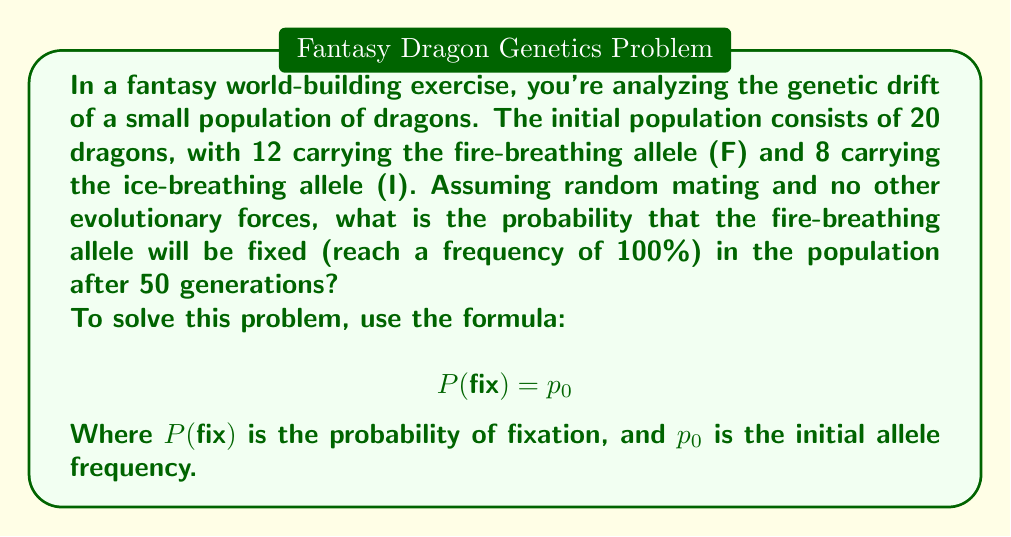Help me with this question. To solve this problem, we need to follow these steps:

1. Calculate the initial allele frequency ($p_0$) of the fire-breathing allele (F):

   $p_0 = \frac{\text{Number of F alleles}}{\text{Total number of alleles}}$

   $p_0 = \frac{12}{20} = 0.6$

2. Apply the formula for the probability of fixation:

   $$ P(fix) = p_0 $$

   This formula is derived from the neutral theory of molecular evolution, which states that in the absence of selection, the probability of an allele becoming fixed in a population is equal to its initial frequency.

3. Substitute the value of $p_0$ into the formula:

   $$ P(fix) = 0.6 $$

It's important to note that this probability is independent of the population size and the number of generations, as long as there are no other evolutionary forces at play. The 50 generations mentioned in the question don't affect the calculation, but they provide enough time for genetic drift to potentially lead to fixation.

In the context of world-building, this result suggests that if you were to simulate this scenario multiple times, about 60% of the time, all dragons would end up as fire-breathers after many generations. This could be an interesting element to incorporate into the mythology or history of your fantasy world.
Answer: The probability that the fire-breathing allele will be fixed in the population after 50 generations is 0.6 or 60%. 